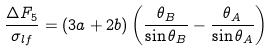<formula> <loc_0><loc_0><loc_500><loc_500>\frac { \Delta F _ { 5 } } { \sigma _ { l f } } = ( 3 a + 2 b ) \left ( \frac { \theta _ { B } } { \sin \theta _ { B } } - \frac { \theta _ { A } } { \sin \theta _ { A } } \right )</formula> 